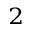<formula> <loc_0><loc_0><loc_500><loc_500>^ { 2 }</formula> 